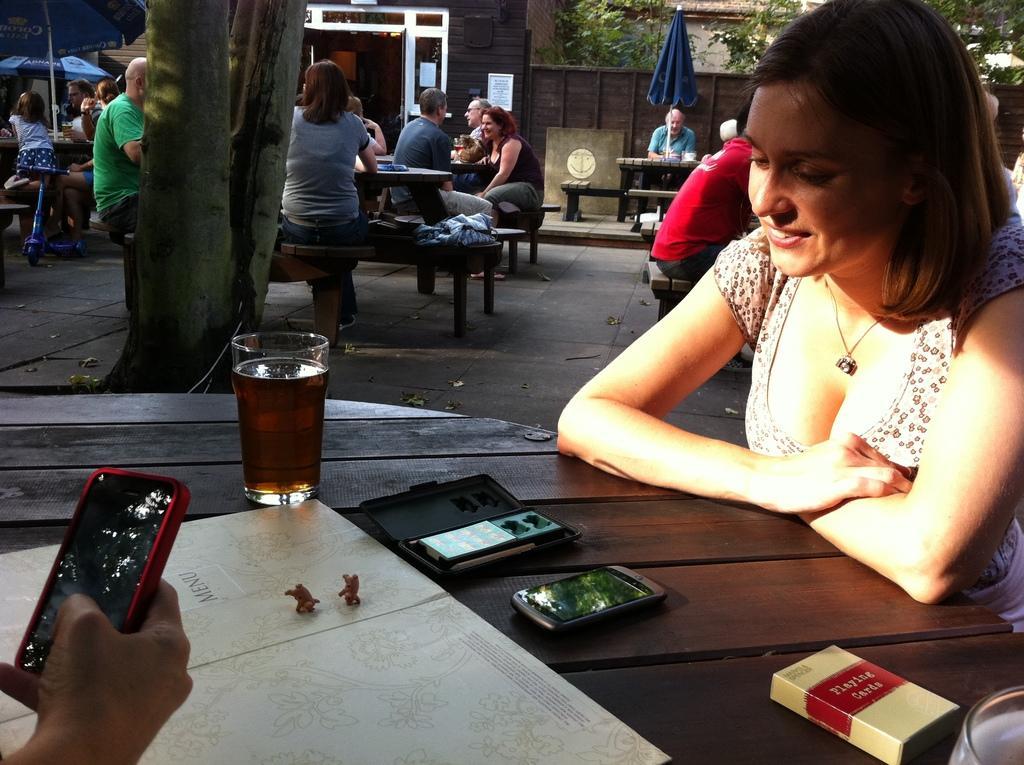Describe this image in one or two sentences. On the right we can see one woman sitting on the chair and she is smiling. In front there is table,on table we can see glass,phone,cigarette packet and paper. On the left there is a human hand holding phone. In the background we can see trees,building,umbrella and group of persons were sitting on the chair around the table. 